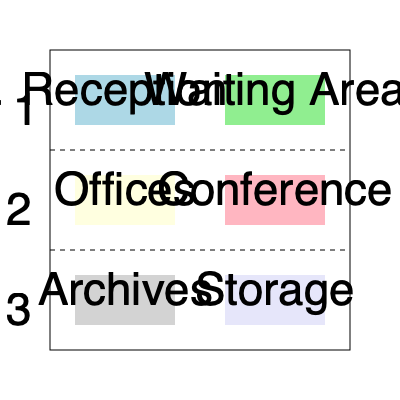Based on the layout of this three-story immigration office building, which floor would you most likely find the legal consultation rooms, and what is directly above this area? To answer this question, let's analyze the layout of the building floor by floor:

1. Floor 1 (top section):
   - Contains Reception and Waiting Area
   - These are typically found on the ground floor for easy access

2. Floor 2 (middle section):
   - Contains Offices and Conference rooms
   - This is the most likely location for legal consultation rooms, as offices are where lawyers would meet with clients

3. Floor 3 (bottom section):
   - Contains Archives and Storage
   - These are typically located on lower or upper floors, away from client-facing areas

Given this analysis:
- The legal consultation rooms are most likely located on Floor 2, in the area labeled "Offices"
- Directly above the Offices area (Floor 2) is the Reception area (Floor 1)

Therefore, the legal consultation rooms are most likely on Floor 2, and the Reception area is directly above them.
Answer: Floor 2; Reception 